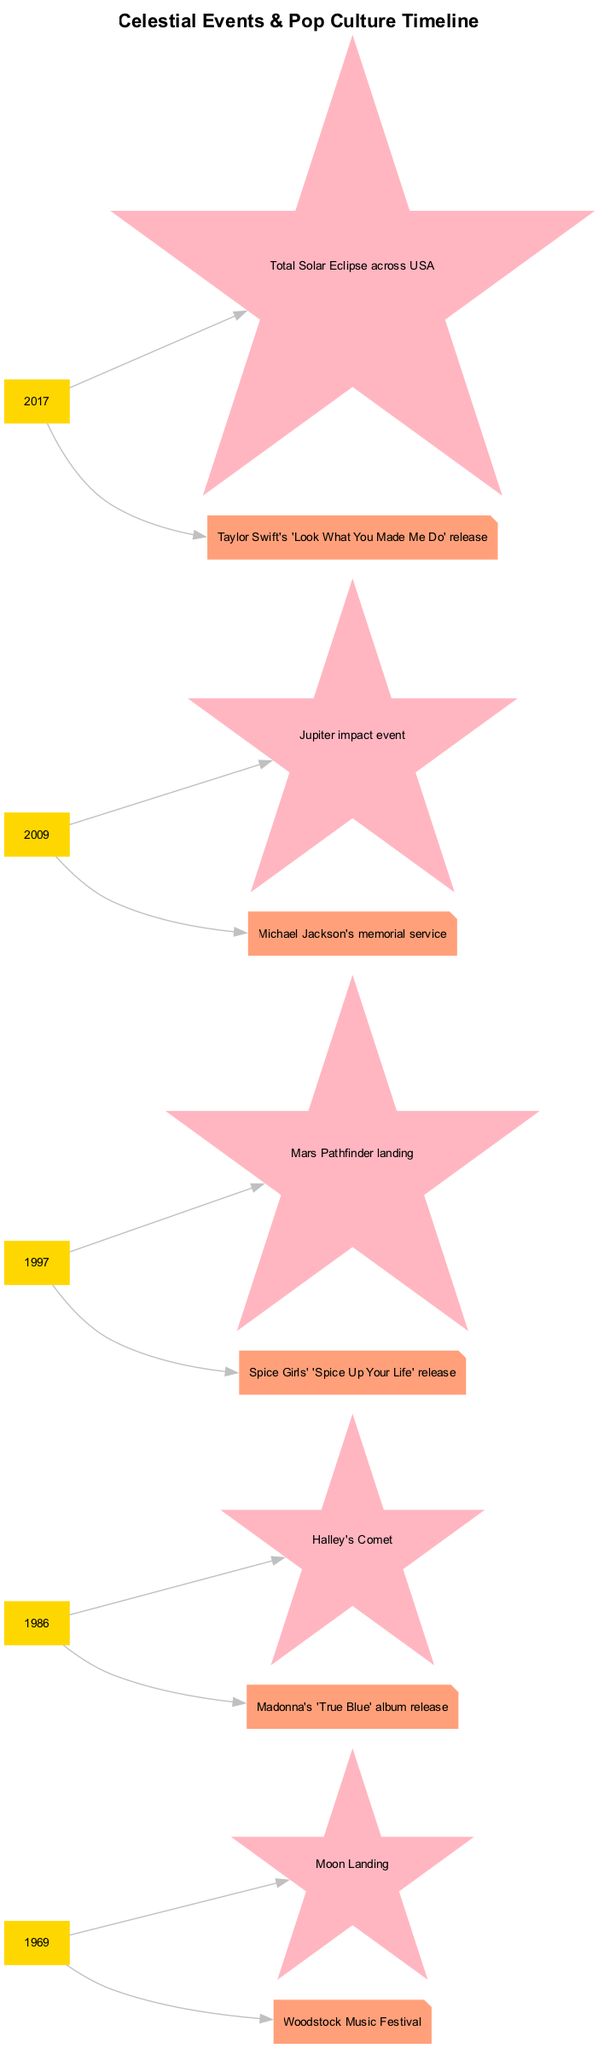What celestial event occurred on July 20, 1969? The diagram shows that the event linked to this date is the Moon Landing, which is indicated in light pink within the celestial events.
Answer: Moon Landing What pop culture event coincided with the Halley's Comet in 1986? The diagram connects the date January 28, 1986, to the pop culture event, which is Madonna's 'True Blue' album release, shown in lightsalmon.
Answer: Madonna's 'True Blue' album release How many significant events are shown in the timeline? Counting all the events depicted in the diagram reveals a total of five events, each corresponding to a date and notable occurrence.
Answer: 5 What celestial event is linked to the Spice Girls' song in 1997? The diagram indicates that the Spice Girls' 'Spice Up Your Life' release is related to the Mars Pathfinder landing, both represented in their respective sections.
Answer: Mars Pathfinder landing Which pop culture event is associated with the Total Solar Eclipse in 2017? The timeline shows that the Total Solar Eclipse across the USA in 2017 corresponds to Taylor Swift's 'Look What You Made Me Do' release, demonstrating a connection.
Answer: Taylor Swift's 'Look What You Made Me Do' release What color represents the years in the diagram? In the diagram, the years are presented in gold, which can be identified by the box shape and the color attribute assigned to the year nodes.
Answer: Gold What celestial event was significant in 2009? The diagram depicts the Jupiter impact event as the notable celestial occurrence for the year 2009, categorized under the celestial events.
Answer: Jupiter impact event Which decade saw both the Moon Landing and the Woodstock Music Festival? By examining the timeline, we can see that both events occurred in the decade of the 1960s. This is affirmed by the date and corresponding cultural significance.
Answer: 1960s What is the relationship between the Mars Pathfinder landing and the Spice Girls? The diagram illustrates a direct connection where both the Mars Pathfinder landing and the Spice Girls' 'Spice Up Your Life' release fall under the year 1997, reflecting a simultaneous occurrence.
Answer: 1997 